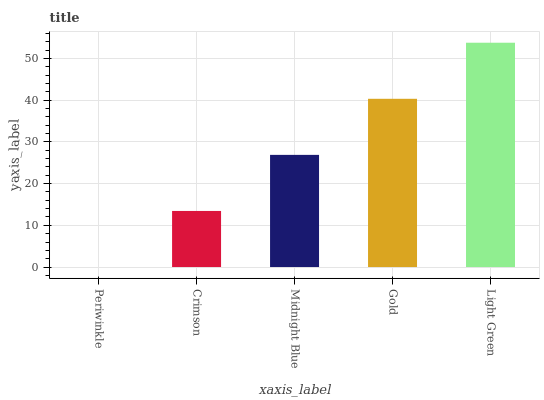Is Periwinkle the minimum?
Answer yes or no. Yes. Is Light Green the maximum?
Answer yes or no. Yes. Is Crimson the minimum?
Answer yes or no. No. Is Crimson the maximum?
Answer yes or no. No. Is Crimson greater than Periwinkle?
Answer yes or no. Yes. Is Periwinkle less than Crimson?
Answer yes or no. Yes. Is Periwinkle greater than Crimson?
Answer yes or no. No. Is Crimson less than Periwinkle?
Answer yes or no. No. Is Midnight Blue the high median?
Answer yes or no. Yes. Is Midnight Blue the low median?
Answer yes or no. Yes. Is Periwinkle the high median?
Answer yes or no. No. Is Light Green the low median?
Answer yes or no. No. 